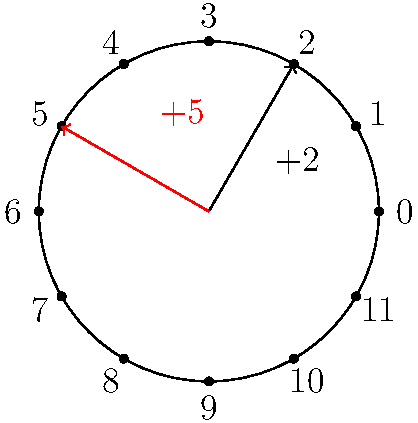Consider the cyclic group $(\mathbb{Z}_{12}, +)$ represented by a clock face. If we start at 0 and apply the operation $+2$ four times, followed by $+5$ three times, what is the final position on the clock? Let's approach this step-by-step:

1) First, we apply $+2$ four times:
   $0 \xrightarrow{+2} 2 \xrightarrow{+2} 4 \xrightarrow{+2} 6 \xrightarrow{+2} 8$

2) Now, we're at position 8 on the clock.

3) Next, we apply $+5$ three times:
   $8 \xrightarrow{+5} 1 \xrightarrow{+5} 6 \xrightarrow{+5} 11$

   Note: When we go past 11, we wrap around to 0, 1, 2, etc.

4) Alternatively, we can calculate this algebraically:
   $$(4 \times 2) + (3 \times 5) \equiv 8 + 15 \equiv 23 \equiv 11 \pmod{12}$$

5) Therefore, after all operations, we end up at position 11 on the clock.

This problem demonstrates how cyclic groups can be visualized using clock arithmetic, where addition wraps around after reaching the group's order (in this case, 12).
Answer: 11 